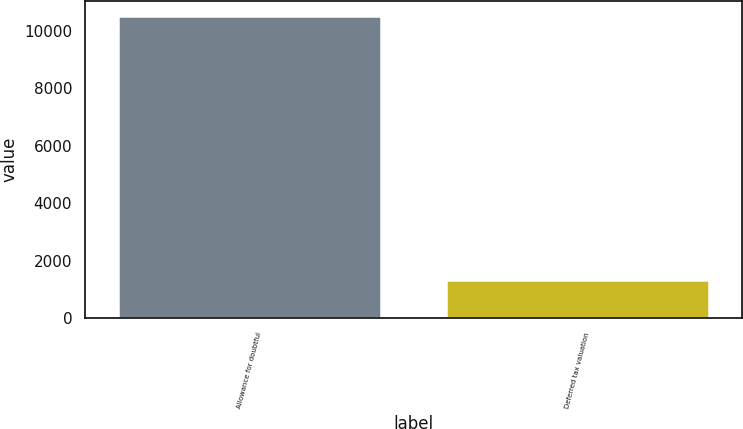<chart> <loc_0><loc_0><loc_500><loc_500><bar_chart><fcel>Allowance for doubtful<fcel>Deferred tax valuation<nl><fcel>10504<fcel>1320<nl></chart> 